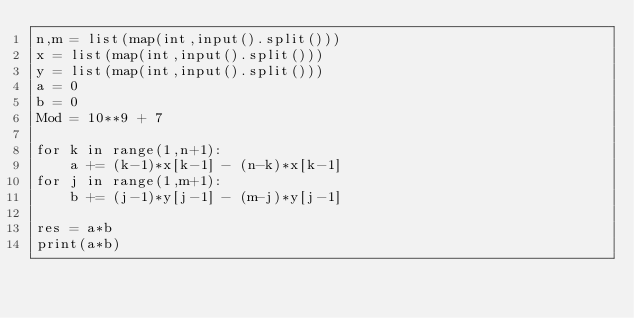<code> <loc_0><loc_0><loc_500><loc_500><_Python_>n,m = list(map(int,input().split()))
x = list(map(int,input().split()))
y = list(map(int,input().split()))
a = 0
b = 0
Mod = 10**9 + 7

for k in range(1,n+1):
    a += (k-1)*x[k-1] - (n-k)*x[k-1]
for j in range(1,m+1):
    b += (j-1)*y[j-1] - (m-j)*y[j-1]

res = a*b
print(a*b)</code> 